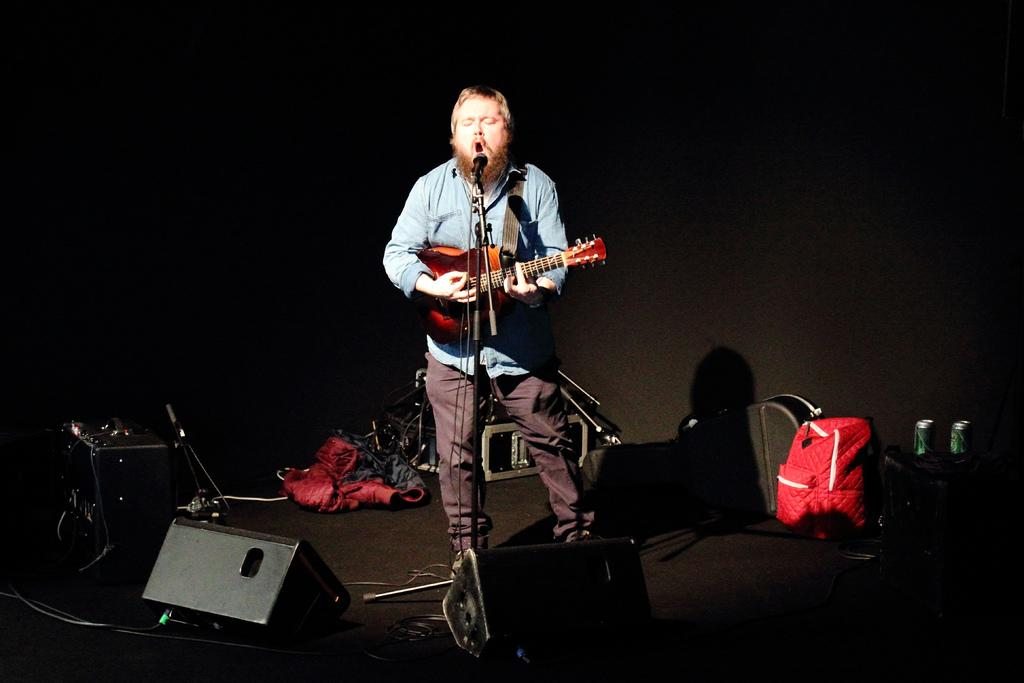What is the overall color scheme of the background in the image? The background of the image is dark. What can be seen on the platform in the image? A device, a backpack, tins, and a guitar bag are visible on the platform. What is the man on the platform doing? The man is singing and playing a guitar. What is the man using to amplify his voice in the image? There is a microphone in front of the man. What type of quiver is the man using to hold his arrows while playing the guitar? There is no quiver present in the image, and the man is not using any arrows while playing the guitar. What is the man's position on the top of the platform in the image? The man is standing on the platform, but there is no specific mention of his position being at the top. 